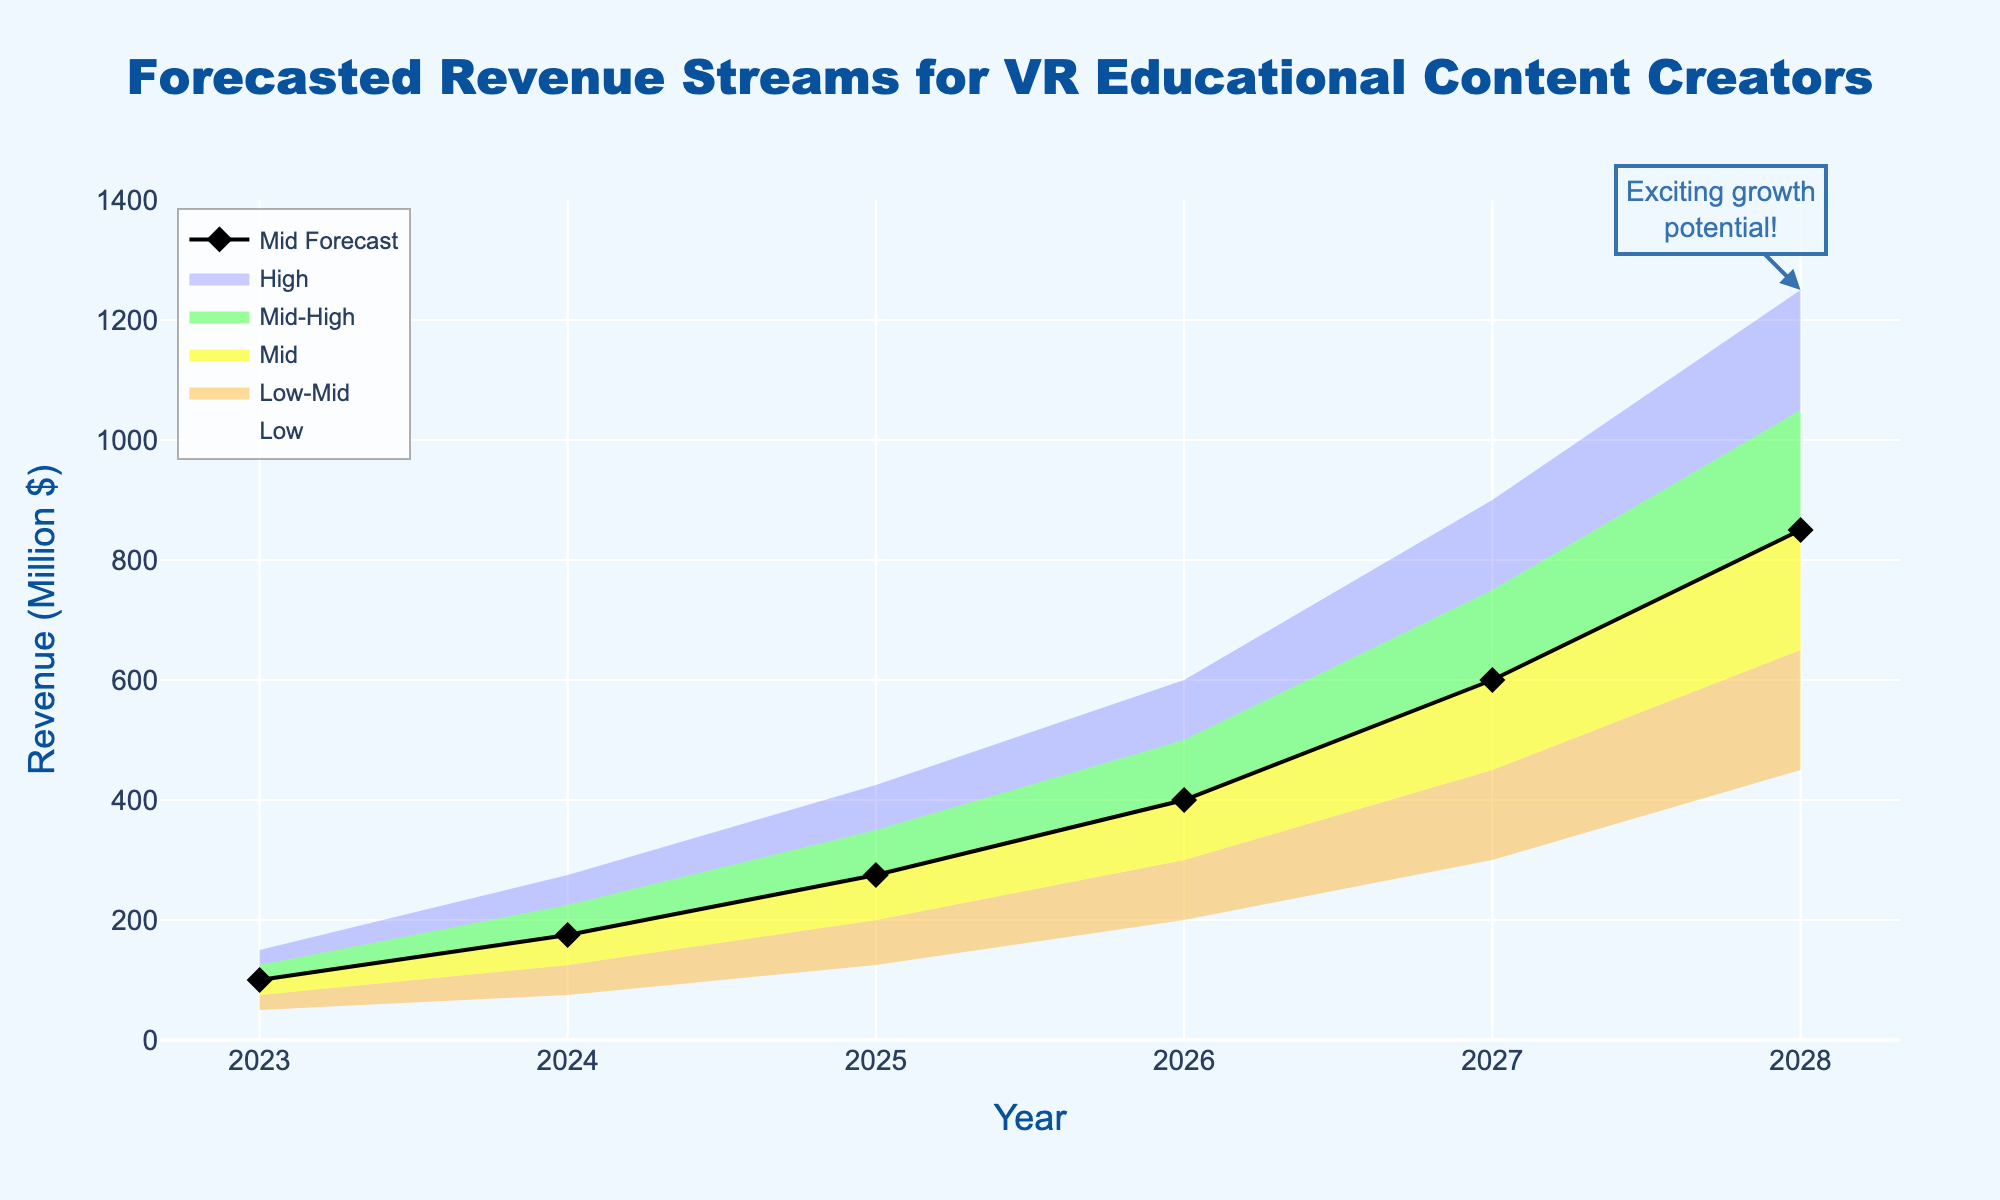What is the title of the figure? The title is displayed at the top of the chart and reads "Forecasted Revenue Streams for VR Educational Content Creators".
Answer: Forecasted Revenue Streams for VR Educational Content Creators How many years are represented in the chart? The x-axis of the chart shows years from 2023 to 2028, which totals six years.
Answer: 6 What is the lowest forecasted revenue in 2023? The lowest forecasted revenue for 2023 is shown by the "Low" line on the y-axis, which is 50 million dollars.
Answer: 50 million dollars In which year is the midpoint forecasted revenue the highest? The midpoint forecast for revenue is illustrated with a black line. The highest point on this line is at 2028.
Answer: 2028 What is the difference between the highest and lowest revenue forecasts for 2025? The highest forecast for 2025 is 425 million dollars, and the lowest is 125 million dollars. The difference is 425 - 125.
Answer: 300 million dollars Does the forecast show any negative growth trends? Observing the chart, all revenue forecasts show an increasing trend over the years, so there are no negative growth trends.
Answer: No What is the revenue forecast range (from lowest to highest) for 2027? In 2027, the lowest revenue forecast is 300 million dollars, and the highest is 900 million dollars. The range is 900 - 300.
Answer: 600 million dollars Which year shows the largest expected increase in revenue for the midpoint forecast? The midpoint forecast increases gradually each year. The largest expected increase can be found by comparing the differences between consecutive years. From 2024 to 2025, the midpoint increases from 175 to 275 million dollars, an increase of 100 million dollars. This is the largest increase.
Answer: 2025 What is the mid-high forecasted revenue for 2026? The mid-high revenue forecast for 2026 can be seen on the y-axis and is marked at 500 million dollars.
Answer: 500 million dollars At the end of the forecast period, what can we infer about the growth potential for VR educational content creators? An annotation on the chart points to exciting growth potential in 2028 with revenues reaching up to 1250 million dollars, which signifies a highly positive outlook.
Answer: Highly positive growth potential 